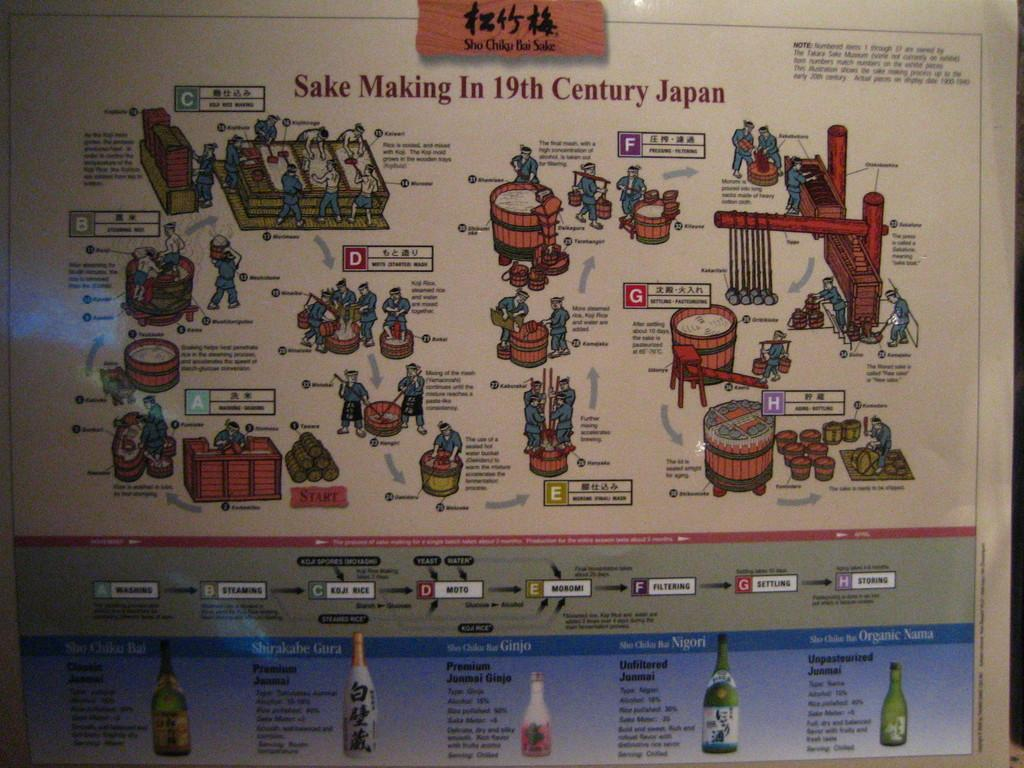What is present in the image that contains both images and text? There is a poster in the image that contains images and text. What type of cake is being served in the image? There is no cake present in the image; it only features a poster with images and text. Is there a stocking hanging on the wall in the image? There is no stocking visible in the image; it only features a poster with images and text. 